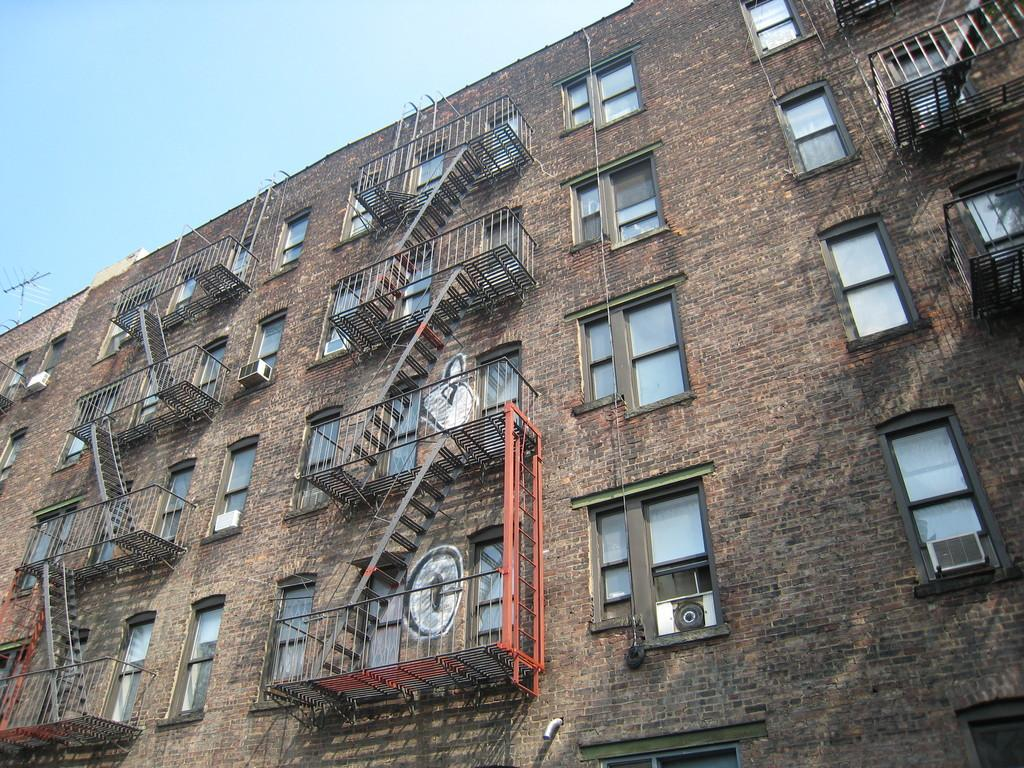What type of structure is in the image? There is a building present in the image. What feature can be seen on the building? There are windows on the building. What architectural element is visible in the image? There are stairs in the image. What safety feature is present in the image? Railings are visible in the image. What is the color of the sky in the image? The sky is blue at the top of the image. What type of pies are being served in the building in the image? There is no indication of pies being served in the building or anywhere in the image. 